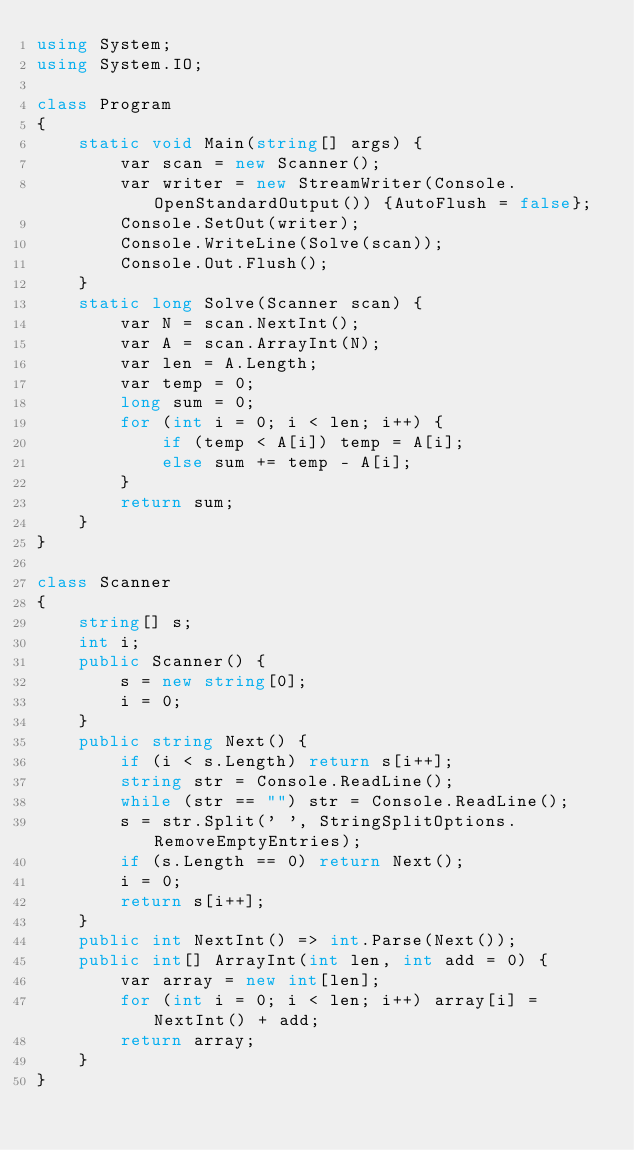Convert code to text. <code><loc_0><loc_0><loc_500><loc_500><_C#_>using System;
using System.IO;

class Program
{
    static void Main(string[] args) {
        var scan = new Scanner();
        var writer = new StreamWriter(Console.OpenStandardOutput()) {AutoFlush = false};
        Console.SetOut(writer);
        Console.WriteLine(Solve(scan));
        Console.Out.Flush();
    }
    static long Solve(Scanner scan) {
        var N = scan.NextInt();
        var A = scan.ArrayInt(N);
        var len = A.Length;
        var temp = 0;
        long sum = 0;
        for (int i = 0; i < len; i++) {
            if (temp < A[i]) temp = A[i];
            else sum += temp - A[i];
        }
        return sum;
    }
}

class Scanner
{
    string[] s;
    int i;
    public Scanner() {
        s = new string[0];
        i = 0;
    }
    public string Next() {
        if (i < s.Length) return s[i++];
        string str = Console.ReadLine();
        while (str == "") str = Console.ReadLine();
        s = str.Split(' ', StringSplitOptions.RemoveEmptyEntries);
        if (s.Length == 0) return Next();
        i = 0;
        return s[i++];
    }
    public int NextInt() => int.Parse(Next());
    public int[] ArrayInt(int len, int add = 0) {
        var array = new int[len];
        for (int i = 0; i < len; i++) array[i] = NextInt() + add;
        return array;
    }
}</code> 